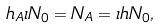Convert formula to latex. <formula><loc_0><loc_0><loc_500><loc_500>h _ { A } \iota N _ { 0 } = N _ { A } = \iota h N _ { 0 } ,</formula> 